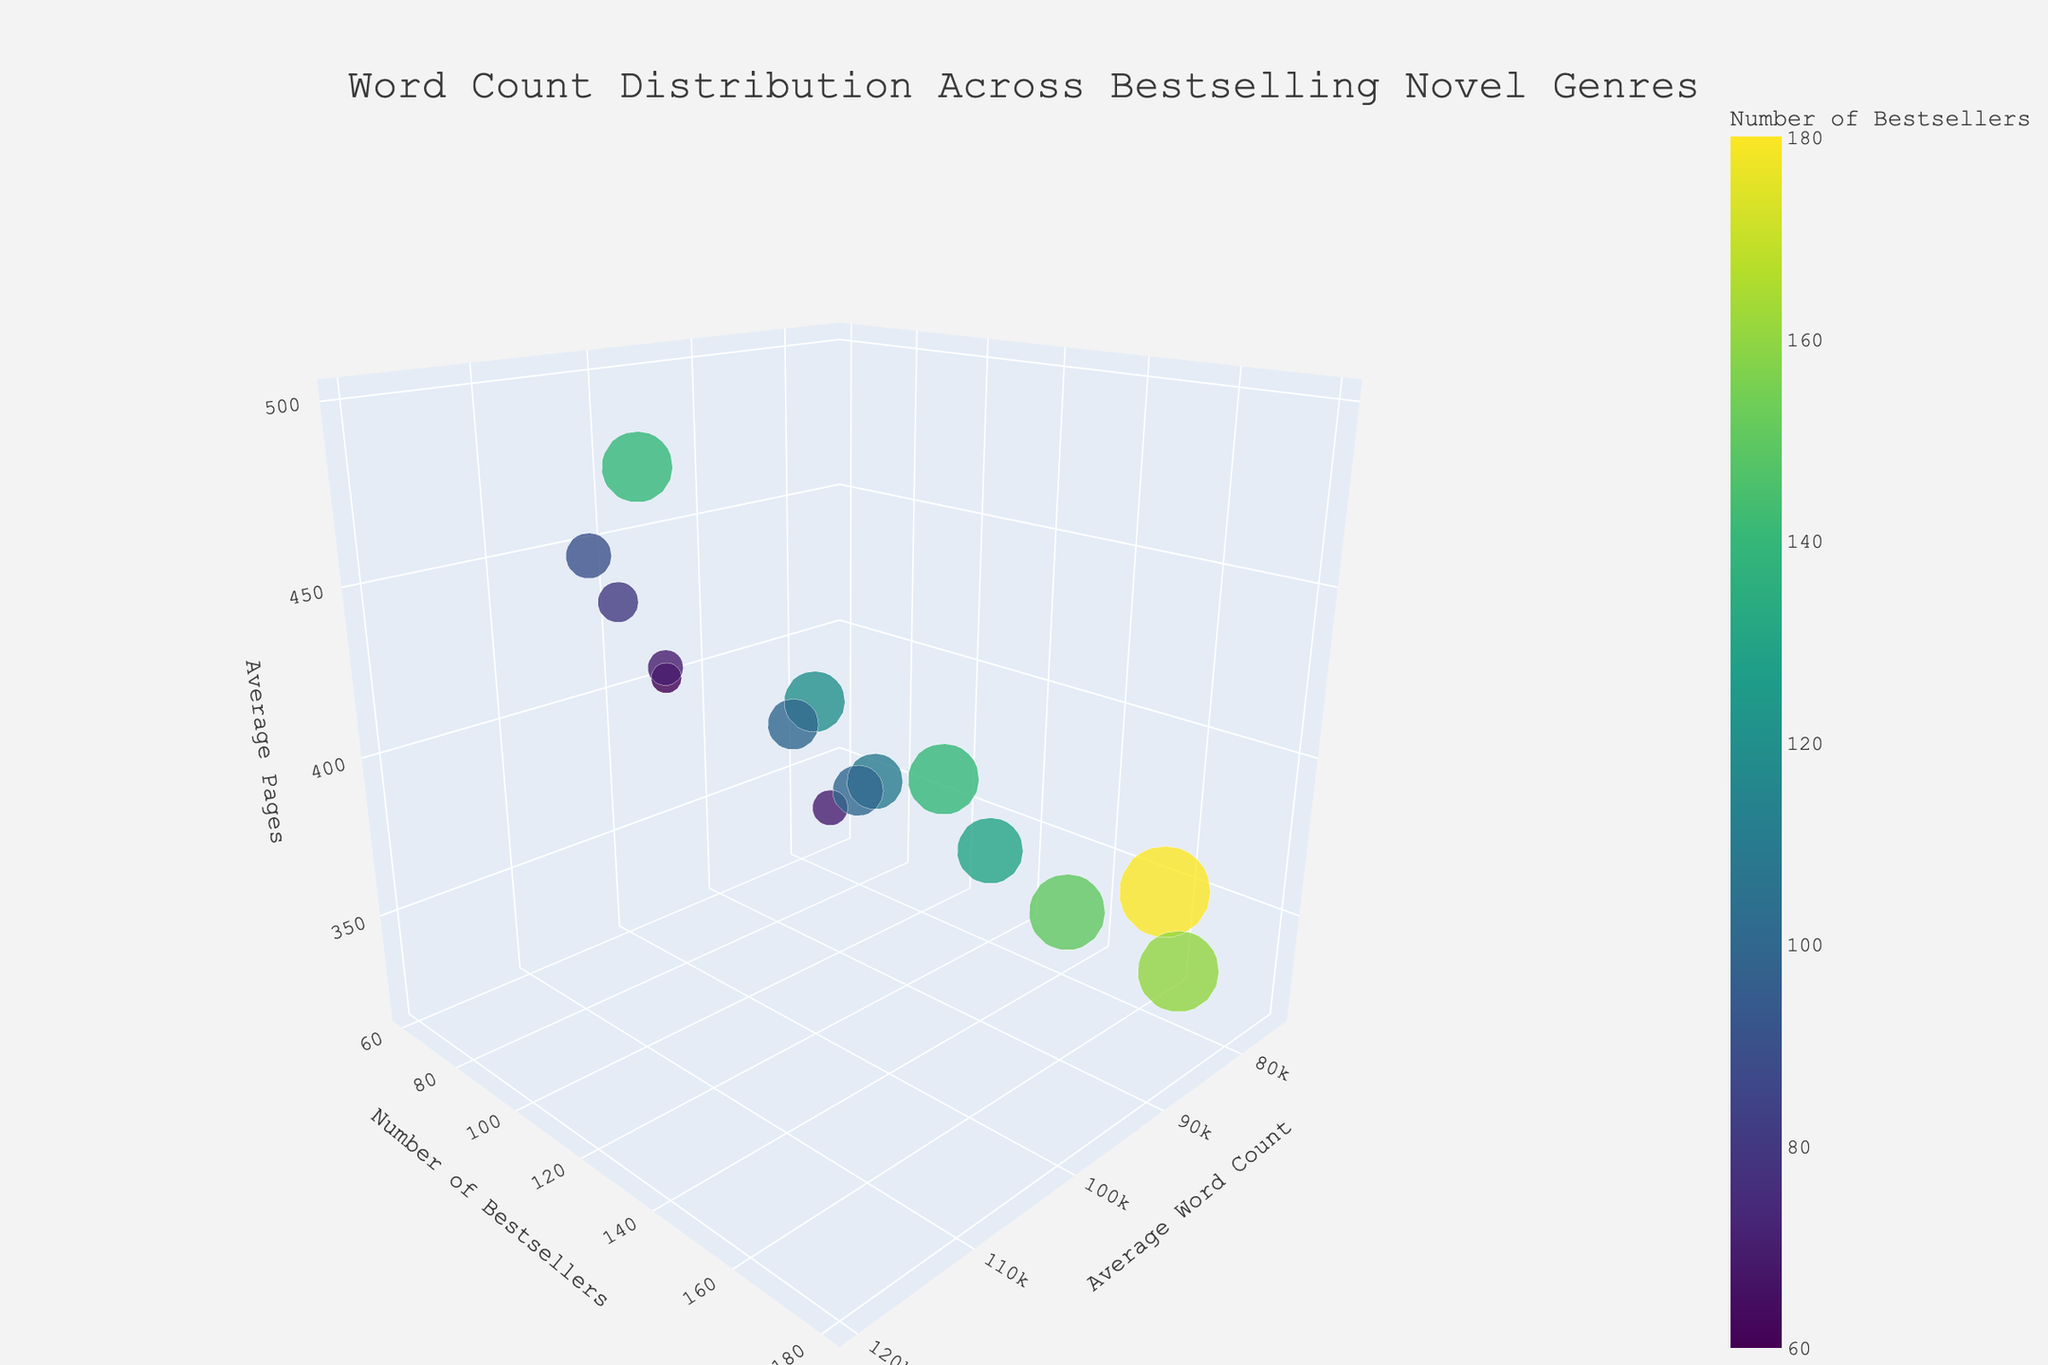What is the title of the 3D bubble chart? The title of the figure is usually found at the top center of the plot. In this case, it is clearly displayed.
Answer: Word Count Distribution Across Bestselling Novel Genres Which genre has the highest average word count? To find the genre with the highest average word count, look for the data point with the maximum value along the "Average Word Count" axis. The genre with the highest x-axis value is Fantasy.
Answer: Fantasy How many genres have an average page count of 400? To find the genres with an average page count of 400, check the z-axis values. Literary Fiction, Dystopian, and Crime all intersect at the 400 unit on the z-axis.
Answer: 3 Which genre has the largest number of bestsellers? Look for the genre with the highest value along the "Number of Bestsellers" axis. The genre with the largest y-axis value is Mystery/Thriller.
Answer: Mystery/Thriller What is the average number of pages for genres with fewer than 100 bestsellers? Identify the data points on the plot with a "Number of Bestsellers" count of less than 100, then calculate the average of their "Average Pages" values: Literary Fiction (400), Historical Fiction (460), Horror (340), Dystopian (400), Urban Fantasy (410). Sum these values (400 + 460 + 340 + 400 + 410) and divide by 5.
Answer: 402 Which genre has the smallest bubble? The size of the bubble is determined by the number of bestsellers. The smallest bubble corresponds to the genre with the smallest number of bestsellers, which is Horror and Urban Fantasy.
Answer: Horror/Urban Fantasy How does Science Fiction compare to Fantasy in terms of average word count and number of bestsellers? On the x-axis (Average Word Count), compare the values for Science Fiction (100,000) and Fantasy (120,000). On the y-axis (Number of Bestsellers), compare the values for Science Fiction (120) and Fantasy (140). Fantasy has both higher average word count and more bestsellers.
Answer: Fantasy has higher values in both categories What pattern can you derive about the number of bestsellers relative to the average word count? Examine if there's a visible trend between "Number of Bestsellers" and "Average Word Count." It appears that genres with higher average word counts do not necessarily have more bestsellers. For example, Science Fiction has a high word count but fewer bestsellers than Romance.
Answer: No clear correlation How do Romance and Contemporary Fiction compare in terms of average pages? To compare these genres, look at the z-axis values for both. Romance has an average of 350 pages, and Contemporary Fiction has an average of 360 pages, which makes Contemporary Fiction slightly higher.
Answer: Contemporary Fiction What is the average word count range for genres with more than 100 bestsellers? Identify the genres with more than 100 bestsellers: Romance (85,000), Mystery/Thriller (90,000), Science Fiction (100,000), Fantasy (120,000), Young Adult (75,000), Contemporary Fiction (85,000), Women's Fiction (90,000). Find the smallest and largest word counts in this set.
Answer: 75,000 to 120,000 